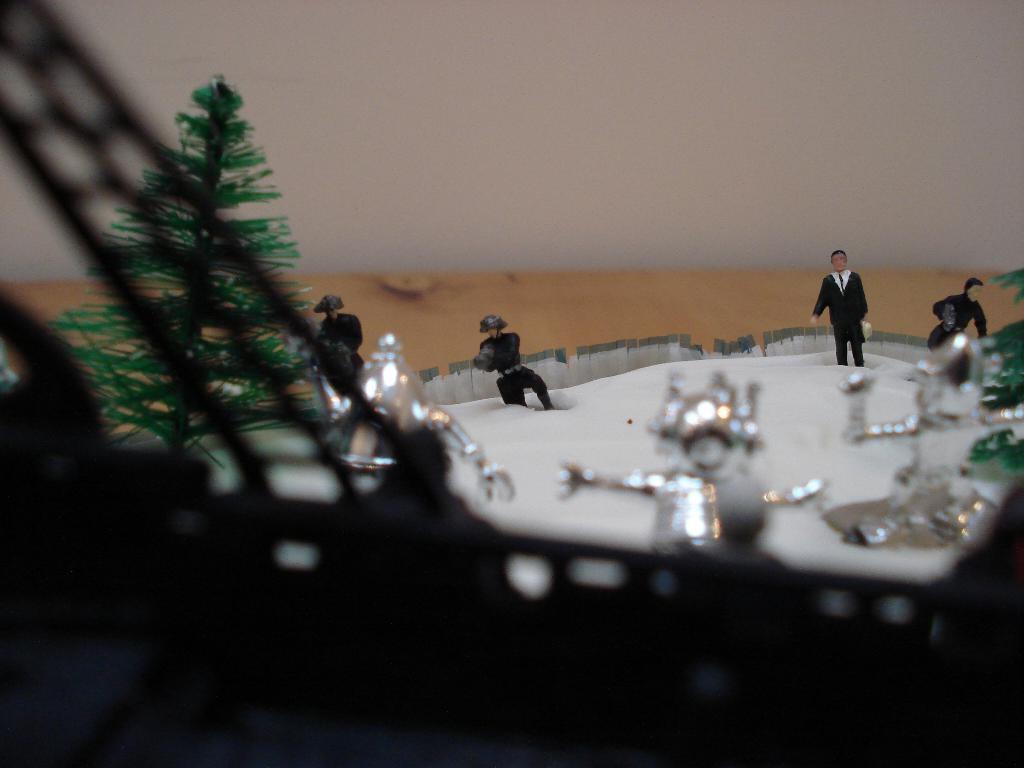Please provide a concise description of this image. In this image there are miniatures of trees, people and objects. In the background of the image there is a wall. 